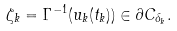<formula> <loc_0><loc_0><loc_500><loc_500>\zeta _ { k } = \Gamma ^ { - 1 } ( u _ { k } ( t _ { k } ) ) \in \partial C _ { \delta _ { k } } .</formula> 